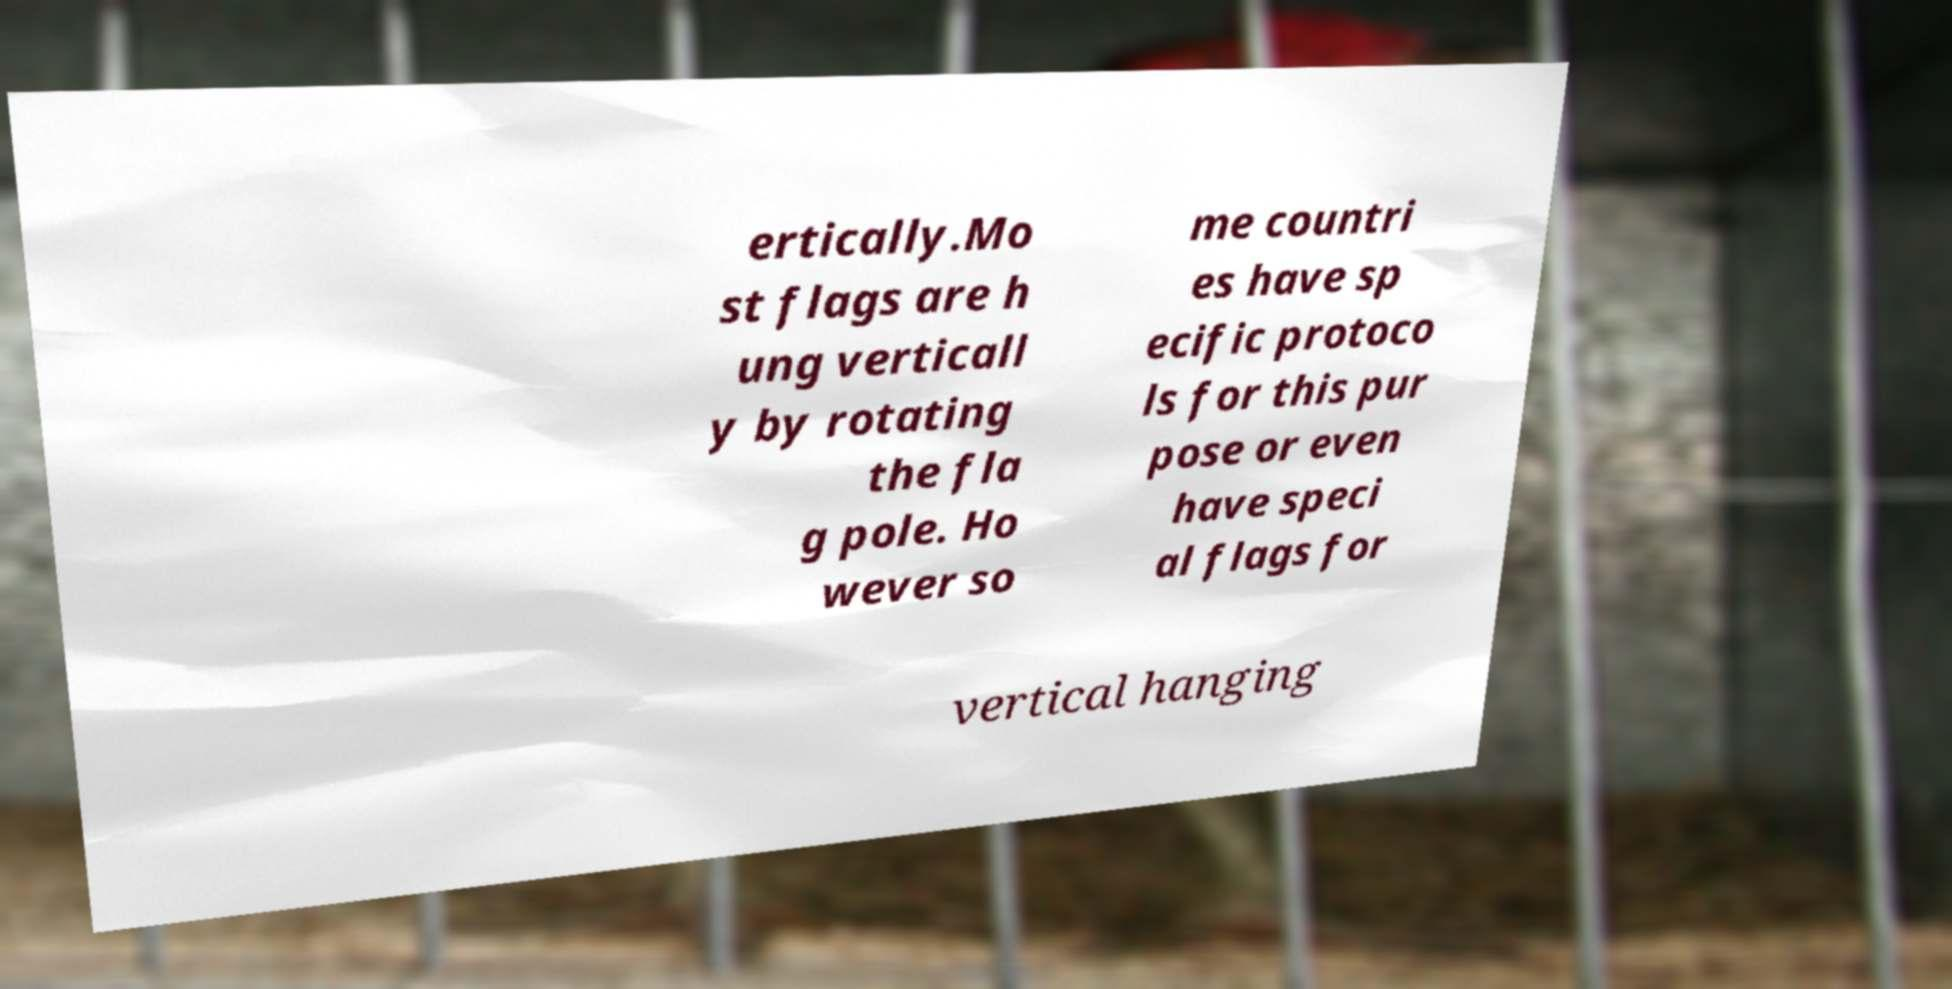Please read and relay the text visible in this image. What does it say? ertically.Mo st flags are h ung verticall y by rotating the fla g pole. Ho wever so me countri es have sp ecific protoco ls for this pur pose or even have speci al flags for vertical hanging 